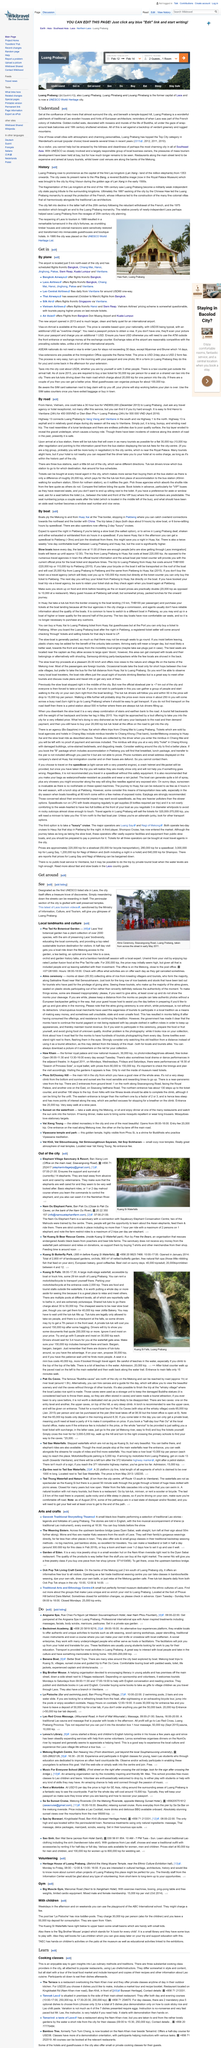Point out several critical features in this image. Luang Prabang, a place situated at the confluence of two rivers, is known for its unique charm and cultural heritage. Luang Prabang, a place known for its temple-topped hill, is located in a place that is beneath it. Luang Prabang's traditional Lao wooden houses, a patchwork of cultural heritage, are one of the things that readers should understand. 